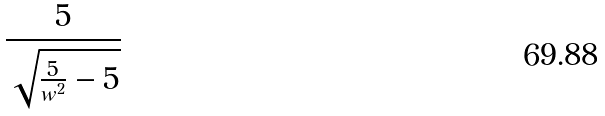Convert formula to latex. <formula><loc_0><loc_0><loc_500><loc_500>\frac { 5 } { \sqrt { \frac { 5 } { w ^ { 2 } } - 5 } }</formula> 